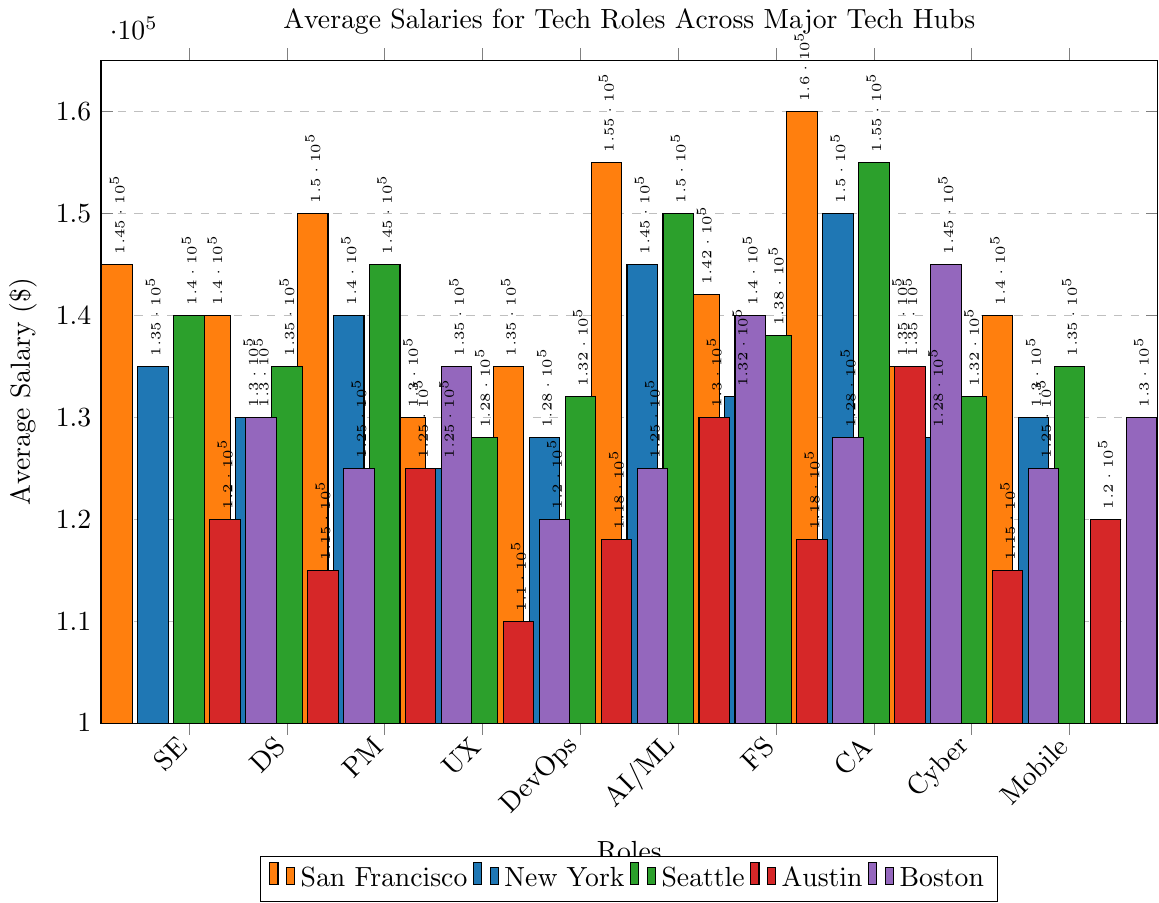what is the average salary difference between a Software Engineer and a UX Designer in San Francisco? The salary for a Software Engineer in San Francisco is $145,000 and for a UX Designer, it is $130,000. The difference is $145,000 - $130,000 = $15,000
Answer: $15,000 Which role has the highest average salary in New York? By comparing the average salaries of all roles in New York: Software Engineer ($135,000), Data Scientist ($130,000), Product Manager ($140,000), UX Designer ($125,000), DevOps Engineer ($128,000), AI/ML Engineer ($145,000), Full Stack Developer ($132,000), Cloud Architect ($150,000), Cybersecurity Analyst ($128,000), and Mobile App Developer ($130,000), we see that Cloud Architect has the highest at $150,000
Answer: Cloud Architect What is the total average salary of a Product Manager in all cities combined? Sum the salaries for a Product Manager across all cities: San Francisco ($150,000), New York ($140,000), Seattle ($145,000), Austin ($125,000), and Boston ($135,000). The total is $150,000 + $140,000 + $145,000 + $125,000 + $135,000 = $695,000
Answer: $695,000 Which role shows the least variation in average salary across all cities? By examining the variation in salaries for each role: Software Engineer ($145,000, $135,000, $140,000, $120,000, $130,000), Data Scientist ($140,000, $130,000, $135,000, $115,000, $125,000), Product Manager ($150,000, $140,000, $145,000, $125,000, $135,000), UX Designer ($130,000, $125,000, $128,000, $110,000, $120,000), DevOps Engineer ($135,000, $128,000, $132,000, $118,000, $125,000), AI/ML Engineer ($155,000, $145,000, $150,000, $130,000, $140,000), Full Stack Developer ($142,000, $132,000, $138,000, $118,000, $128,000), Cloud Architect ($160,000, $150,000, $155,000, $135,000, $145,000), Cybersecurity Analyst ($135,000, $128,000, $132,000, $115,000, $125,000), Mobile App Developer ($140,000, $130,000, $135,000, $120,000, $130,000), Full Stack Developer shows the least variation as the differences are $142,000 - $132,000 = $10,000, $138,000 - $118,000 = $20,000, and $128,000 - $118,000 = $10,000
Answer: Full Stack Developer What is the average salary of a Data Scientist in Seattle, Austin, and Boston combined? Sum the salaries for a Data Scientist in Seattle ($135,000), Austin ($115,000), and Boston ($125,000) then divide by the number of cities: ($135,000 + $115,000 + $125,000) / 3 = $375,000 / 3 = $125,000
Answer: $125,000 Compare the average salaries for an AI/ML Engineer and a Full Stack Developer in San Francisco. The average salary for an AI/ML Engineer in San Francisco is $155,000, while for a Full Stack Developer it is $142,000. Thus, the AI/ML Engineer earns $155,000 - $142,000 = $13,000 more
Answer: $13,000 Which hub has the highest overall average salary among all the roles? To find this, we need to calculate the average salary for each hub (city). Sum the salaries for each city and then divide by the number of roles. San Francisco: ($145,000 + $140,000 + $150,000 + $130,000 + $135,000 + $155,000 + $142,000 + $160,000 + $135,000 + $140,000) / 10 = $143,200. New York: ($135,000 + $130,000 + $140,000 + $125,000 + $128,000 + $145,000 + $132,000 + $150,000 + $128,000 + $130,000) / 10 = $134,300. Seattle: ($140,000 + $135,000 + $145,000 + $128,000 + $132,000 + $150,000 + $138,000 + $155,000 + $132,000 + $135,000) / 10 = $139,000. Austin: ($120,000 + $115,000 + $125,000 + $110,000 + $118,000 + $130,000 + $118,000 + $135,000 + $115,000 + $120,000) / 10 = $120,600. Boston: ($130,000 + $125,000 + $135,000 + $120,000 + $125,000 + $140,000 + $128,000 + $145,000 + $125,000 + $130,000) / 10 = $130,300. San Francisco has the highest overall average salary
Answer: San Francisco 